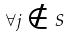Convert formula to latex. <formula><loc_0><loc_0><loc_500><loc_500>\forall j \notin S</formula> 